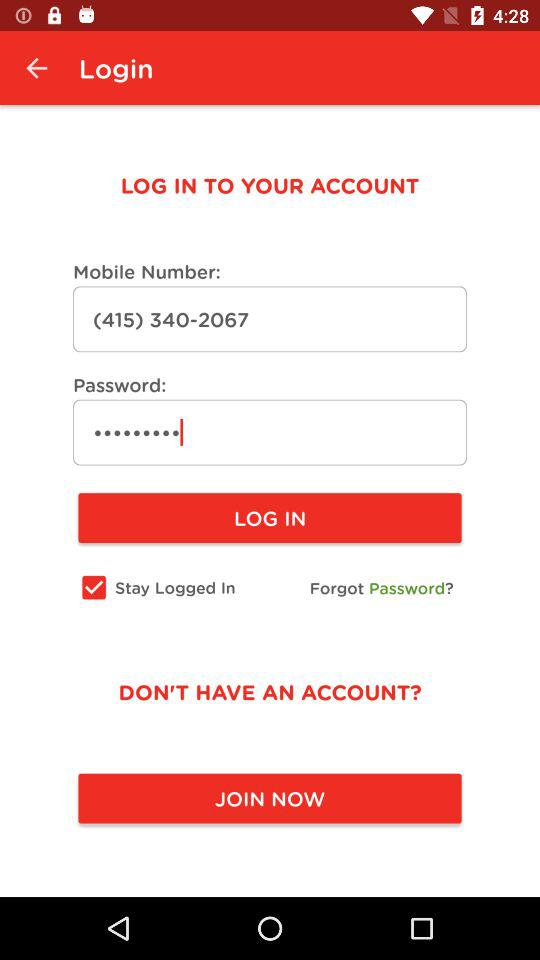What is the status of "Stay Logged In"? The status is "on". 